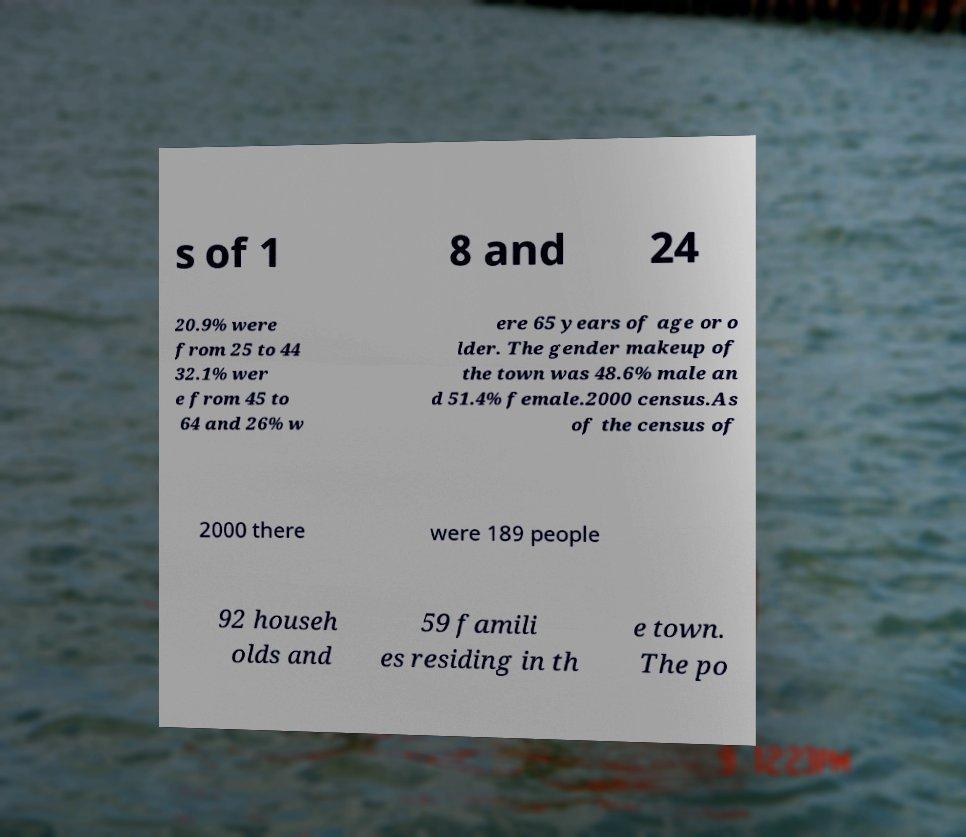Can you accurately transcribe the text from the provided image for me? s of 1 8 and 24 20.9% were from 25 to 44 32.1% wer e from 45 to 64 and 26% w ere 65 years of age or o lder. The gender makeup of the town was 48.6% male an d 51.4% female.2000 census.As of the census of 2000 there were 189 people 92 househ olds and 59 famili es residing in th e town. The po 